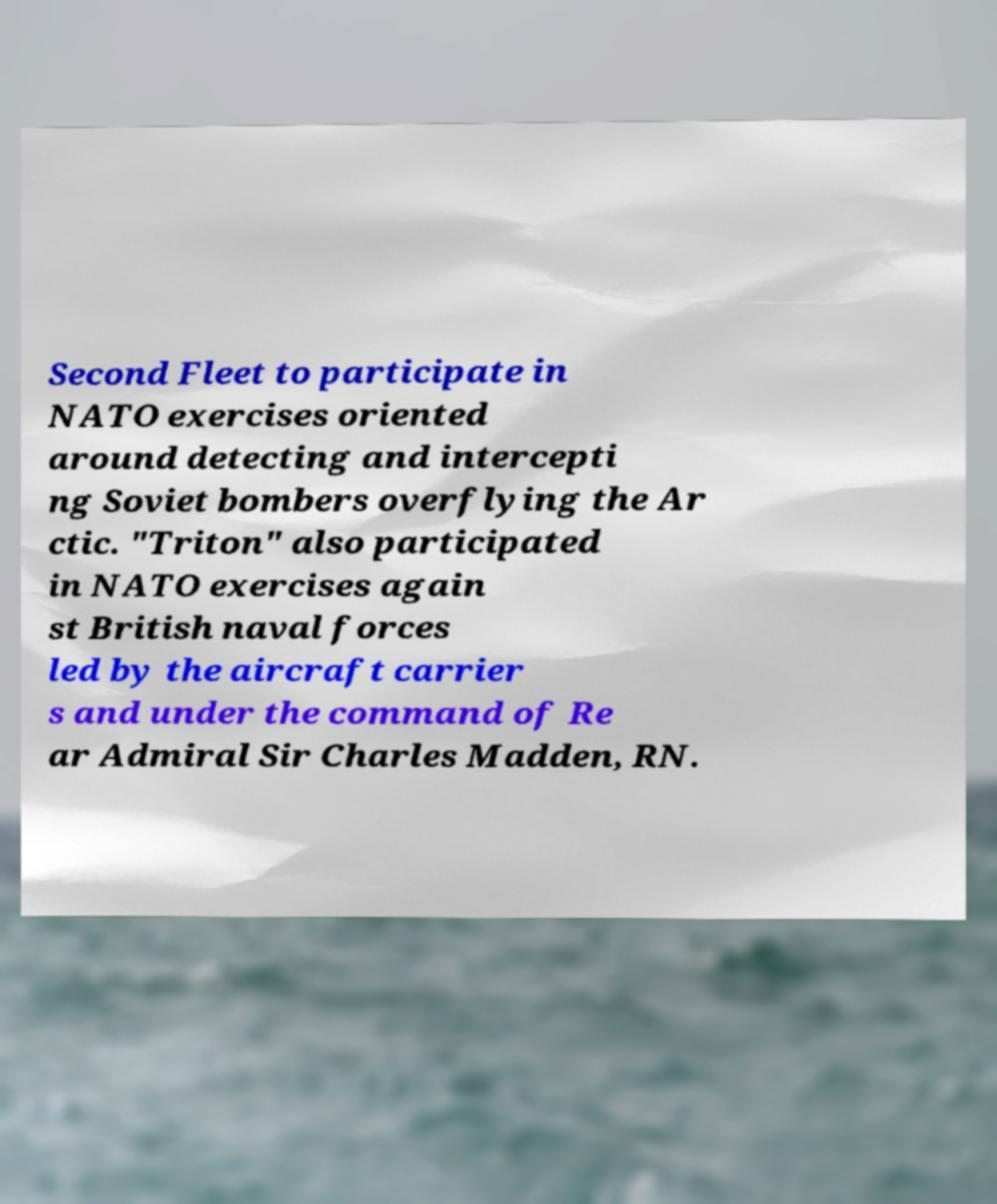Please read and relay the text visible in this image. What does it say? Second Fleet to participate in NATO exercises oriented around detecting and intercepti ng Soviet bombers overflying the Ar ctic. "Triton" also participated in NATO exercises again st British naval forces led by the aircraft carrier s and under the command of Re ar Admiral Sir Charles Madden, RN. 